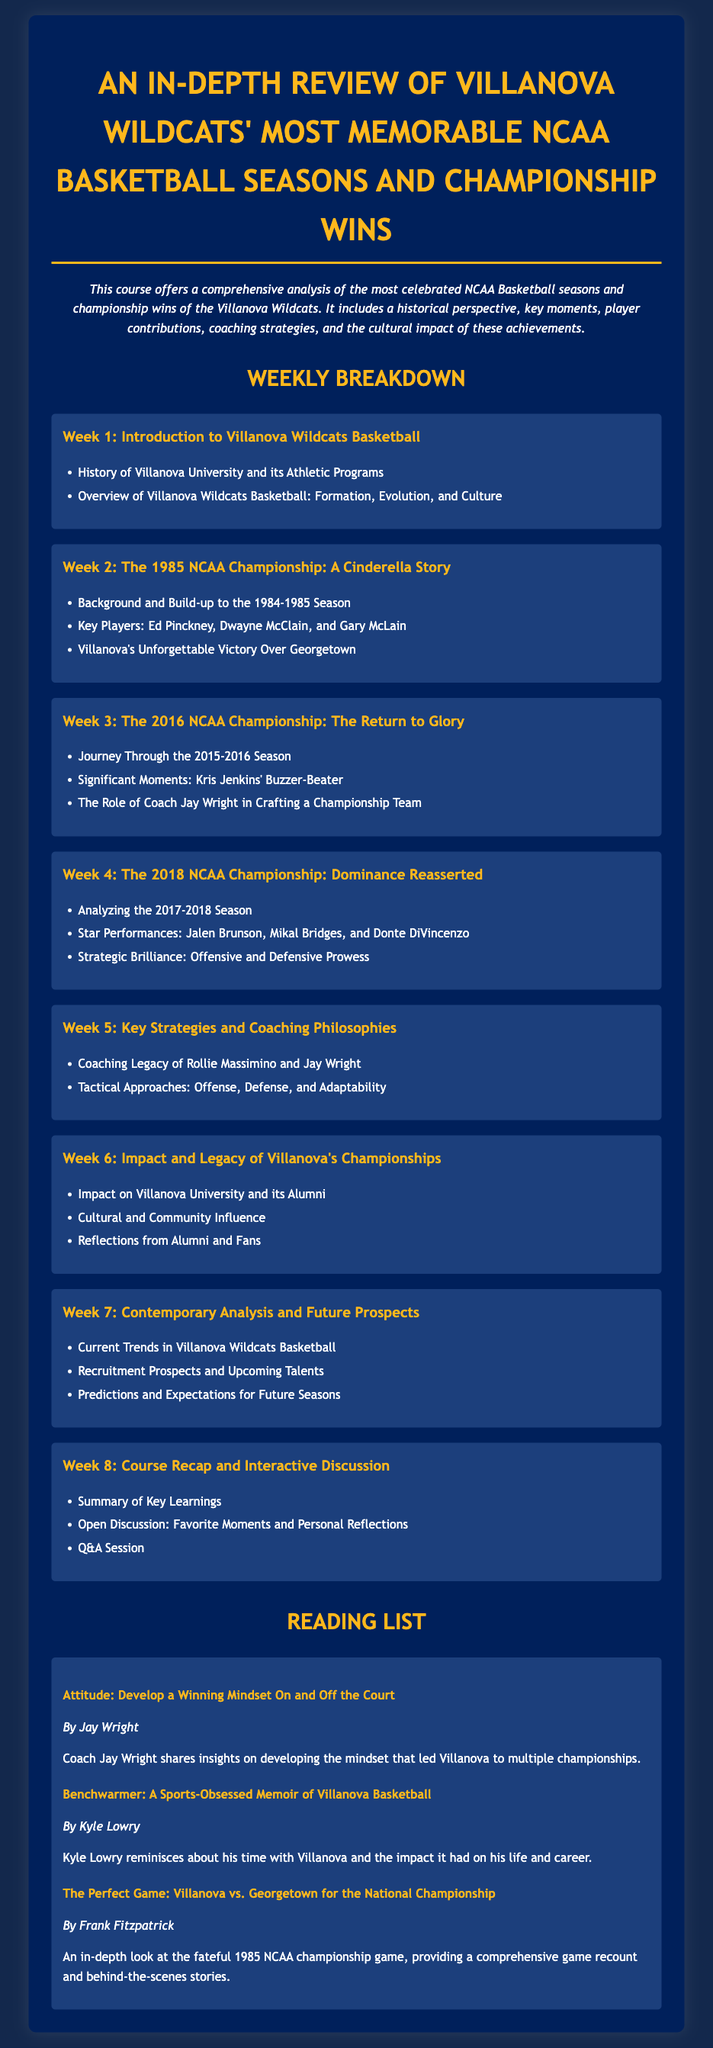What is the title of the course? The title is a prominent heading in the document that indicates what the course is about.
Answer: An In-depth Review of Villanova Wildcats' Most Memorable NCAA Basketball Seasons and Championship Wins Who is the author of the reading titled "Attitude: Develop a Winning Mindset On and Off the Court"? This information can be found in the reading list section where the author’s name is provided under the book title.
Answer: Jay Wright In which week is the 1985 NCAA Championship discussed? The week is specified in the weekly breakdown, along with the topic to be covered for that week.
Answer: Week 2 What significant moment is highlighted in Week 3? The moment is noted in the details of Week 3, emphasizing the relevance of a specific play during the championship.
Answer: Kris Jenkins' Buzzer-Beater How many weeks does the syllabus cover? The total number of weeks is summarized in the weekly breakdown section listing various topics for study throughout the course.
Answer: 8 Which two coaches' legacies are examined in Week 5? The coaches are discussed in the context of their influence and strategies, as outlined in that week's topic.
Answer: Rollie Massimino and Jay Wright What type of influence is assessed in Week 6? This type of influence is elaborated upon in the respective weekly breakdown, mentioning the sociocultural context of the championships.
Answer: Cultural and Community Influence What is the main focus of Week 8? The main focus is conveyed through the list of activities and discussions planned for that week.
Answer: Course Recap and Interactive Discussion 